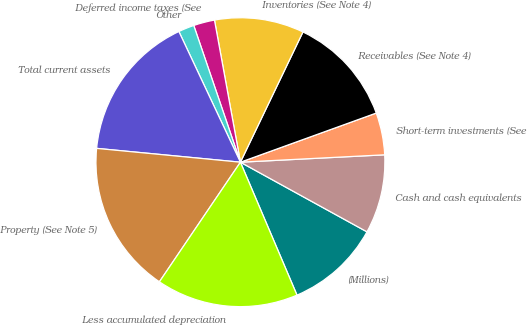Convert chart to OTSL. <chart><loc_0><loc_0><loc_500><loc_500><pie_chart><fcel>(Millions)<fcel>Cash and cash equivalents<fcel>Short-term investments (See<fcel>Receivables (See Note 4)<fcel>Inventories (See Note 4)<fcel>Deferred income taxes (See<fcel>Other<fcel>Total current assets<fcel>Property (See Note 5)<fcel>Less accumulated depreciation<nl><fcel>10.59%<fcel>8.82%<fcel>4.71%<fcel>12.35%<fcel>10.0%<fcel>2.36%<fcel>1.77%<fcel>16.47%<fcel>17.05%<fcel>15.88%<nl></chart> 